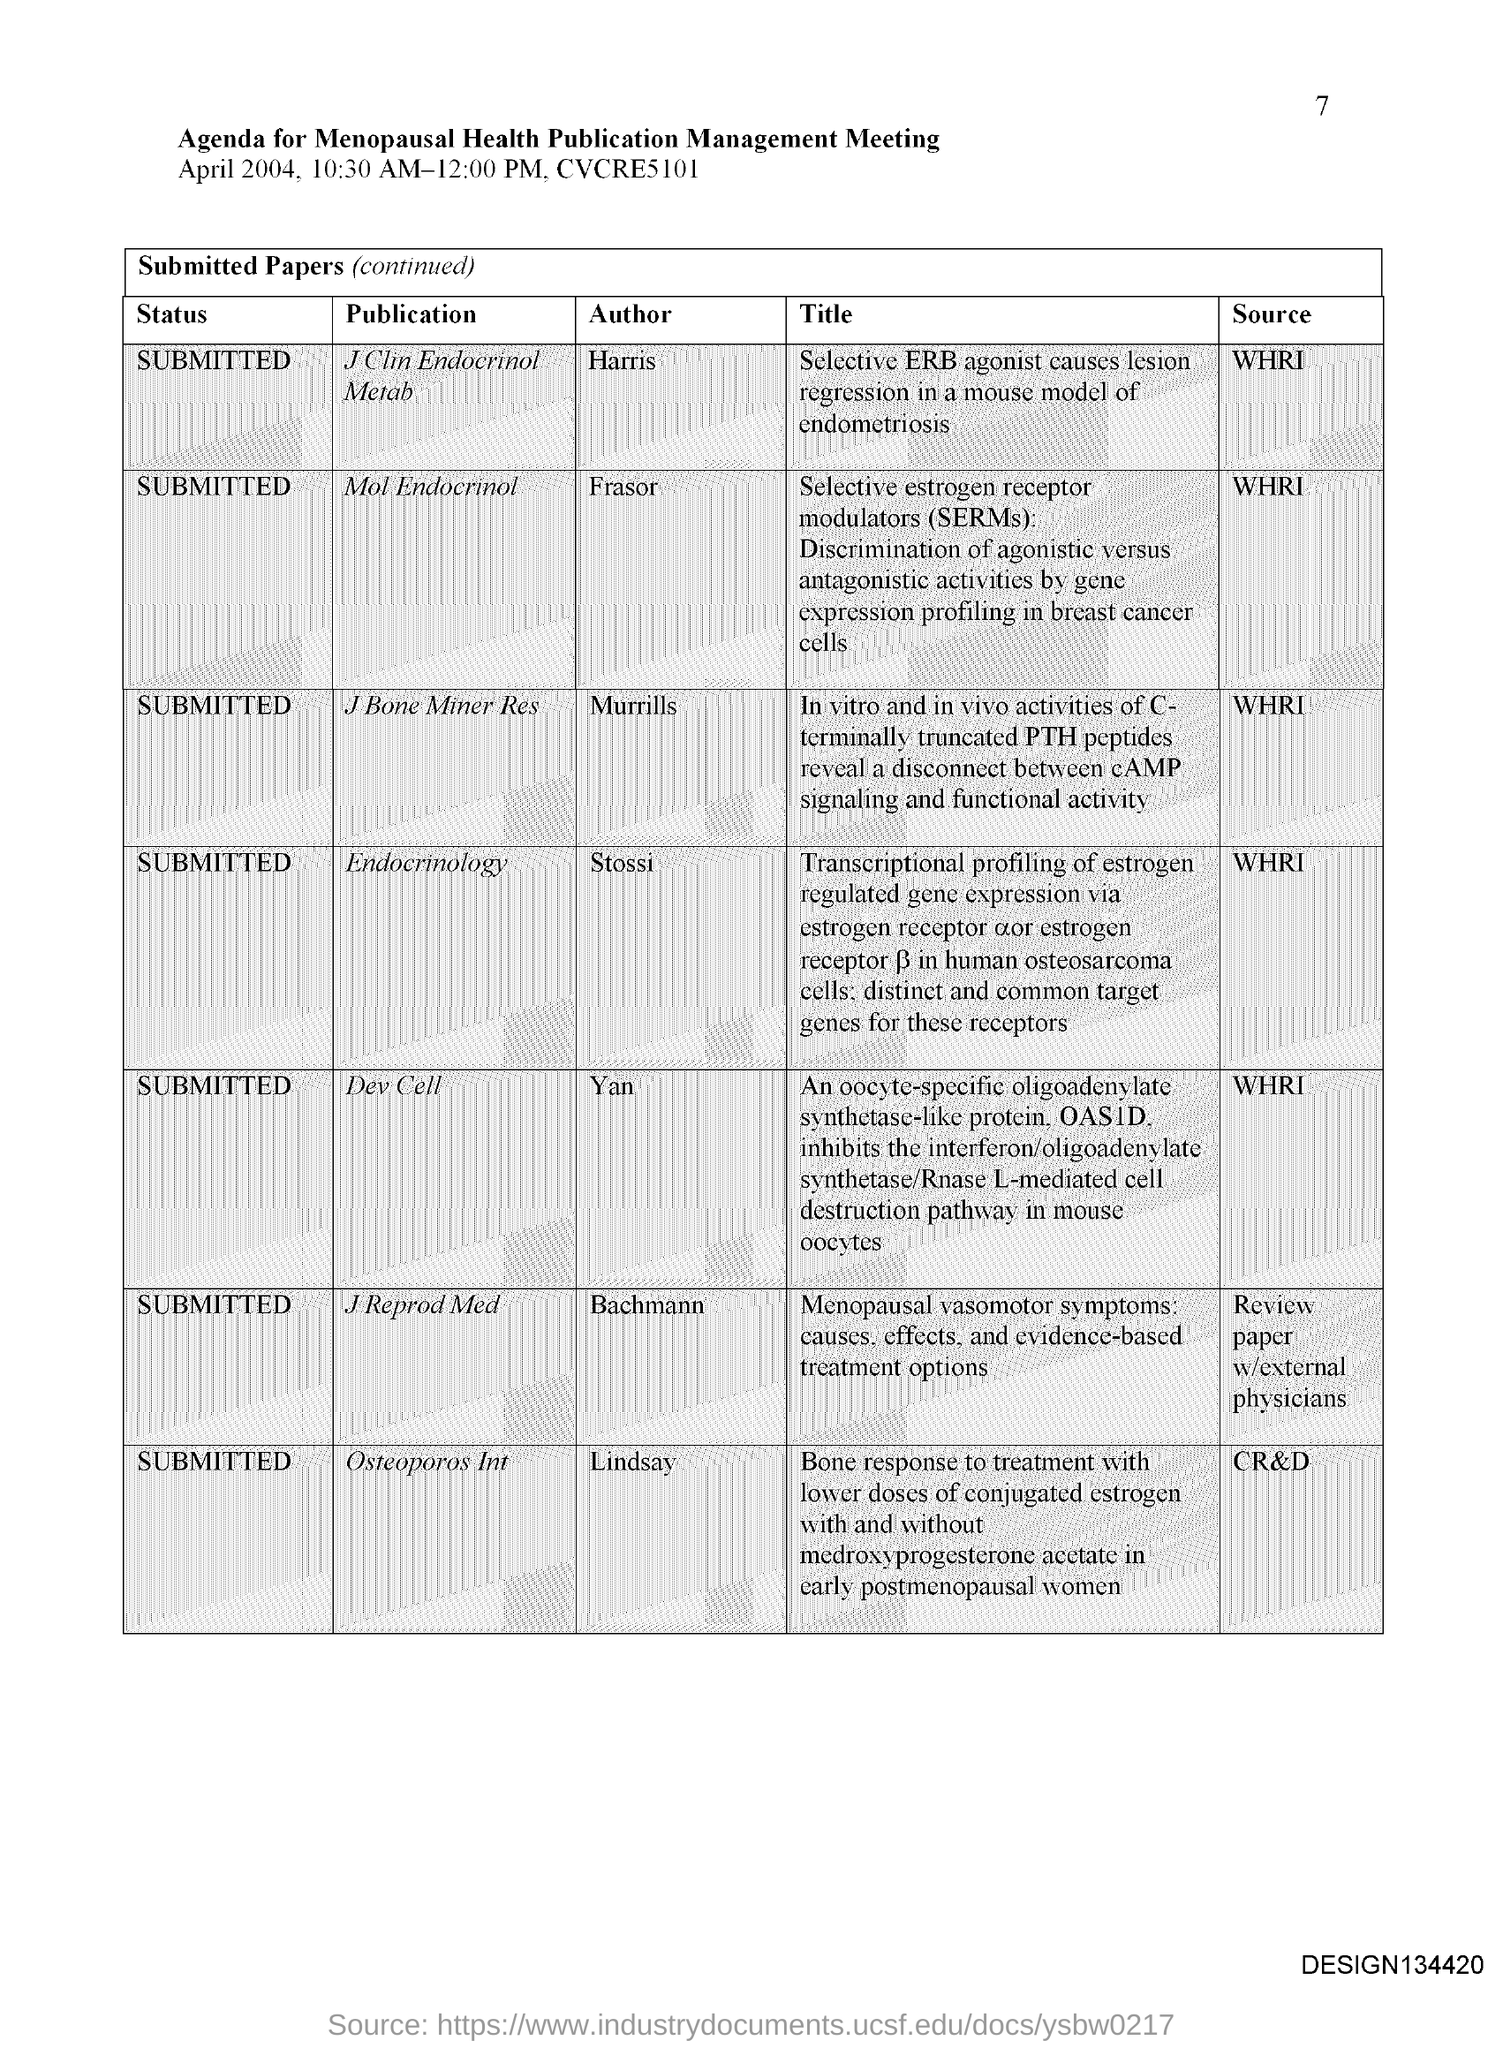Highlight a few significant elements in this photo. The author of the publication "Dev Cell" is Yan. The author of the publication "Mol Endocrinol" is Frassort. The publication "Endocrinology" was authored by Stossi. The author of the publication 'Osteoporos Int' is Lindsay. 